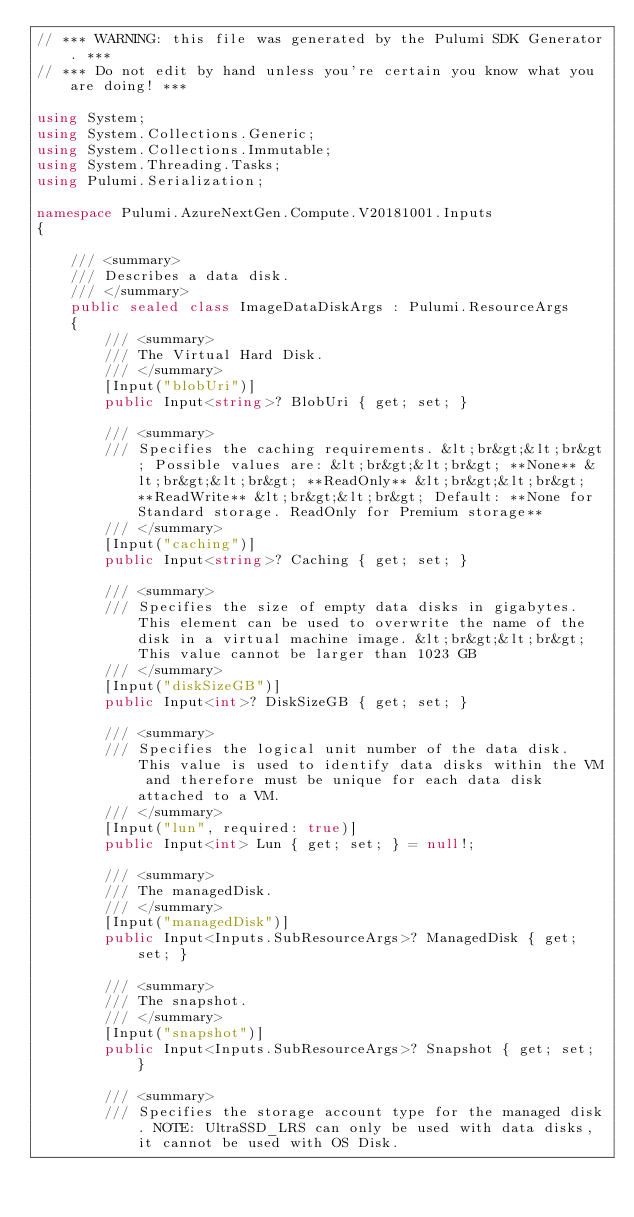Convert code to text. <code><loc_0><loc_0><loc_500><loc_500><_C#_>// *** WARNING: this file was generated by the Pulumi SDK Generator. ***
// *** Do not edit by hand unless you're certain you know what you are doing! ***

using System;
using System.Collections.Generic;
using System.Collections.Immutable;
using System.Threading.Tasks;
using Pulumi.Serialization;

namespace Pulumi.AzureNextGen.Compute.V20181001.Inputs
{

    /// <summary>
    /// Describes a data disk.
    /// </summary>
    public sealed class ImageDataDiskArgs : Pulumi.ResourceArgs
    {
        /// <summary>
        /// The Virtual Hard Disk.
        /// </summary>
        [Input("blobUri")]
        public Input<string>? BlobUri { get; set; }

        /// <summary>
        /// Specifies the caching requirements. &lt;br&gt;&lt;br&gt; Possible values are: &lt;br&gt;&lt;br&gt; **None** &lt;br&gt;&lt;br&gt; **ReadOnly** &lt;br&gt;&lt;br&gt; **ReadWrite** &lt;br&gt;&lt;br&gt; Default: **None for Standard storage. ReadOnly for Premium storage**
        /// </summary>
        [Input("caching")]
        public Input<string>? Caching { get; set; }

        /// <summary>
        /// Specifies the size of empty data disks in gigabytes. This element can be used to overwrite the name of the disk in a virtual machine image. &lt;br&gt;&lt;br&gt; This value cannot be larger than 1023 GB
        /// </summary>
        [Input("diskSizeGB")]
        public Input<int>? DiskSizeGB { get; set; }

        /// <summary>
        /// Specifies the logical unit number of the data disk. This value is used to identify data disks within the VM and therefore must be unique for each data disk attached to a VM.
        /// </summary>
        [Input("lun", required: true)]
        public Input<int> Lun { get; set; } = null!;

        /// <summary>
        /// The managedDisk.
        /// </summary>
        [Input("managedDisk")]
        public Input<Inputs.SubResourceArgs>? ManagedDisk { get; set; }

        /// <summary>
        /// The snapshot.
        /// </summary>
        [Input("snapshot")]
        public Input<Inputs.SubResourceArgs>? Snapshot { get; set; }

        /// <summary>
        /// Specifies the storage account type for the managed disk. NOTE: UltraSSD_LRS can only be used with data disks, it cannot be used with OS Disk.</code> 